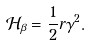Convert formula to latex. <formula><loc_0><loc_0><loc_500><loc_500>\mathcal { H } _ { \beta } = \frac { 1 } { 2 } r \gamma ^ { 2 } .</formula> 